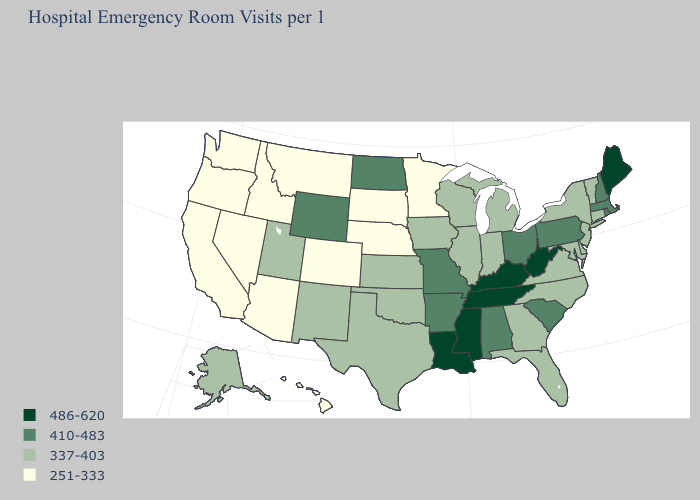What is the value of North Dakota?
Keep it brief. 410-483. Among the states that border New Hampshire , does Massachusetts have the lowest value?
Quick response, please. No. Which states have the lowest value in the USA?
Quick response, please. Arizona, California, Colorado, Hawaii, Idaho, Minnesota, Montana, Nebraska, Nevada, Oregon, South Dakota, Washington. Does the first symbol in the legend represent the smallest category?
Keep it brief. No. What is the value of Alaska?
Short answer required. 337-403. What is the value of Illinois?
Give a very brief answer. 337-403. Which states have the lowest value in the USA?
Answer briefly. Arizona, California, Colorado, Hawaii, Idaho, Minnesota, Montana, Nebraska, Nevada, Oregon, South Dakota, Washington. What is the value of Washington?
Quick response, please. 251-333. Name the states that have a value in the range 251-333?
Write a very short answer. Arizona, California, Colorado, Hawaii, Idaho, Minnesota, Montana, Nebraska, Nevada, Oregon, South Dakota, Washington. Which states hav the highest value in the Northeast?
Be succinct. Maine. Name the states that have a value in the range 251-333?
Be succinct. Arizona, California, Colorado, Hawaii, Idaho, Minnesota, Montana, Nebraska, Nevada, Oregon, South Dakota, Washington. Name the states that have a value in the range 410-483?
Write a very short answer. Alabama, Arkansas, Massachusetts, Missouri, New Hampshire, North Dakota, Ohio, Pennsylvania, Rhode Island, South Carolina, Wyoming. What is the value of Washington?
Quick response, please. 251-333. What is the highest value in the USA?
Answer briefly. 486-620. What is the lowest value in the West?
Short answer required. 251-333. 